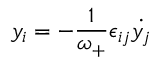<formula> <loc_0><loc_0><loc_500><loc_500>y _ { i } = - \frac { 1 } { \omega _ { + } } \epsilon _ { i j } { \dot { y _ { j } } }</formula> 